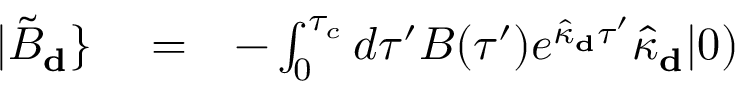Convert formula to latex. <formula><loc_0><loc_0><loc_500><loc_500>\begin{array} { r l r } { | \tilde { B } _ { d } \} } & = } & { - \int _ { 0 } ^ { \tau _ { c } } d \tau ^ { \prime } B ( \tau ^ { \prime } ) e ^ { \hat { \kappa } _ { d } \tau ^ { \prime } } \hat { \kappa } _ { d } | 0 ) } \end{array}</formula> 